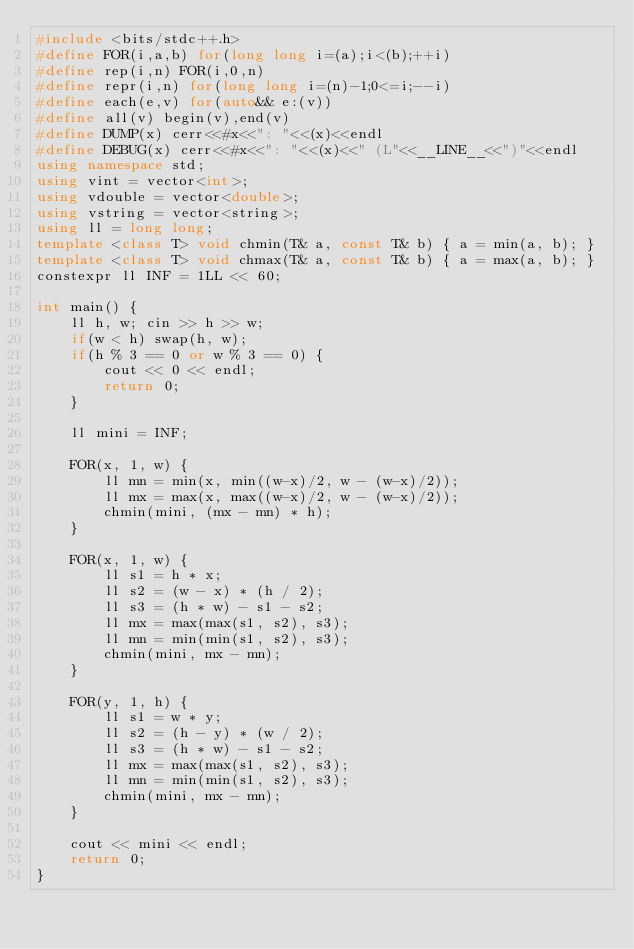<code> <loc_0><loc_0><loc_500><loc_500><_C++_>#include <bits/stdc++.h>
#define FOR(i,a,b) for(long long i=(a);i<(b);++i)
#define rep(i,n) FOR(i,0,n)
#define repr(i,n) for(long long i=(n)-1;0<=i;--i)
#define each(e,v) for(auto&& e:(v))
#define all(v) begin(v),end(v)
#define DUMP(x) cerr<<#x<<": "<<(x)<<endl
#define DEBUG(x) cerr<<#x<<": "<<(x)<<" (L"<<__LINE__<<")"<<endl
using namespace std;
using vint = vector<int>;
using vdouble = vector<double>;
using vstring = vector<string>;
using ll = long long;
template <class T> void chmin(T& a, const T& b) { a = min(a, b); }
template <class T> void chmax(T& a, const T& b) { a = max(a, b); }
constexpr ll INF = 1LL << 60;

int main() {
    ll h, w; cin >> h >> w;
    if(w < h) swap(h, w);
    if(h % 3 == 0 or w % 3 == 0) {
        cout << 0 << endl;
        return 0;
    }

    ll mini = INF;

    FOR(x, 1, w) {
        ll mn = min(x, min((w-x)/2, w - (w-x)/2));
        ll mx = max(x, max((w-x)/2, w - (w-x)/2));
        chmin(mini, (mx - mn) * h);
    }

    FOR(x, 1, w) {
        ll s1 = h * x;
        ll s2 = (w - x) * (h / 2);
        ll s3 = (h * w) - s1 - s2;
        ll mx = max(max(s1, s2), s3);
        ll mn = min(min(s1, s2), s3);
        chmin(mini, mx - mn);
    }

    FOR(y, 1, h) {
        ll s1 = w * y;
        ll s2 = (h - y) * (w / 2);
        ll s3 = (h * w) - s1 - s2;
        ll mx = max(max(s1, s2), s3);
        ll mn = min(min(s1, s2), s3);
        chmin(mini, mx - mn);
    }

    cout << mini << endl;
    return 0;
}
</code> 